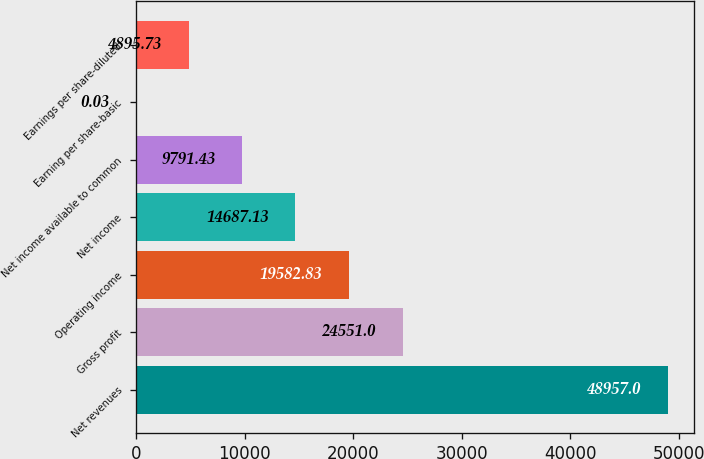Convert chart to OTSL. <chart><loc_0><loc_0><loc_500><loc_500><bar_chart><fcel>Net revenues<fcel>Gross profit<fcel>Operating income<fcel>Net income<fcel>Net income available to common<fcel>Earning per share-basic<fcel>Earnings per share-diluted<nl><fcel>48957<fcel>24551<fcel>19582.8<fcel>14687.1<fcel>9791.43<fcel>0.03<fcel>4895.73<nl></chart> 